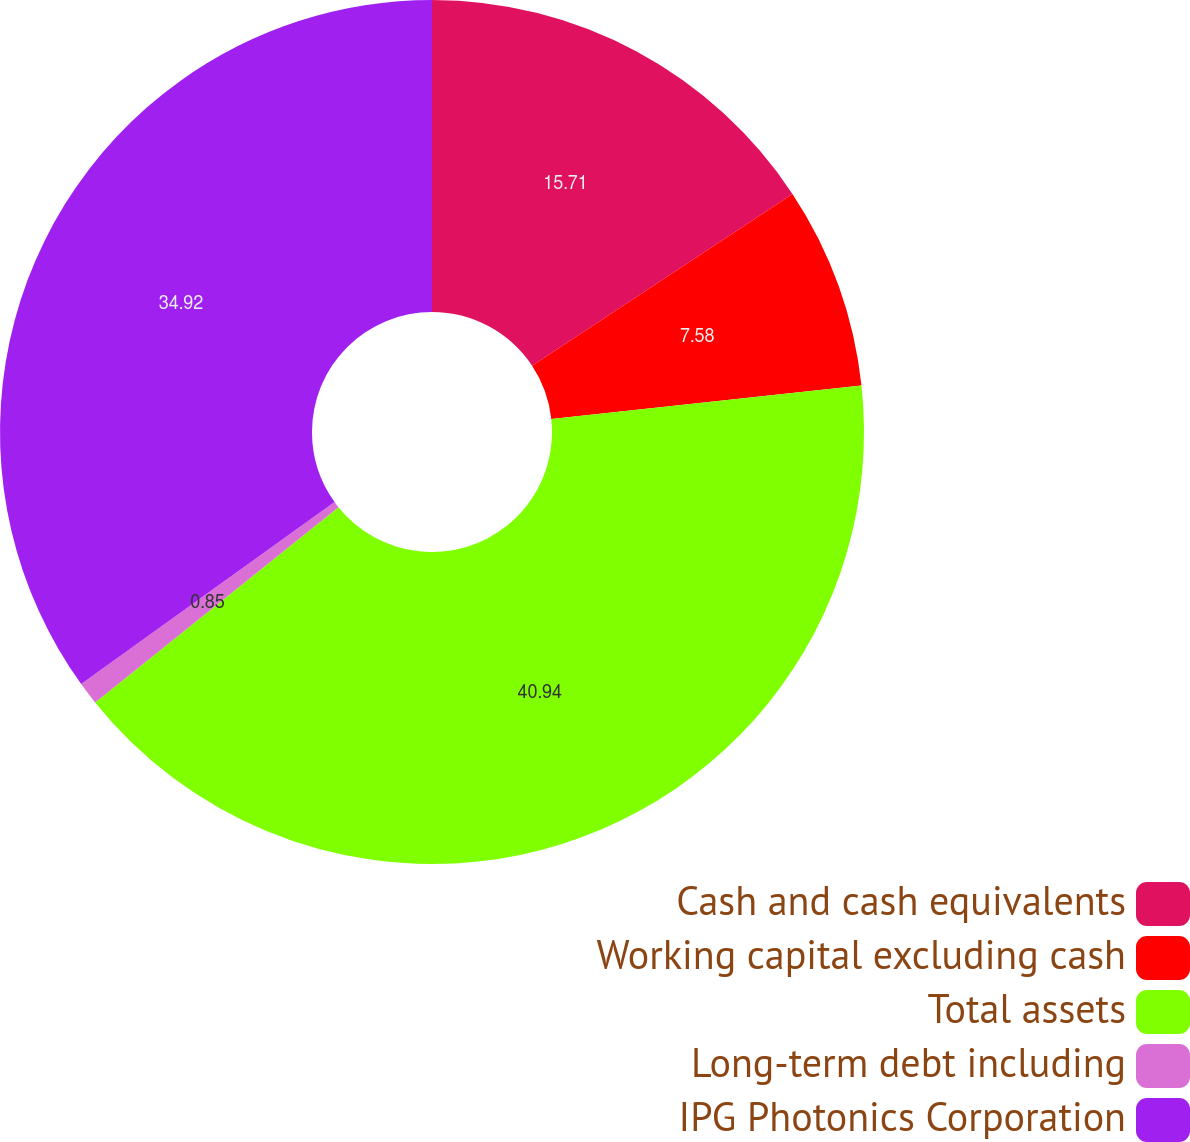<chart> <loc_0><loc_0><loc_500><loc_500><pie_chart><fcel>Cash and cash equivalents<fcel>Working capital excluding cash<fcel>Total assets<fcel>Long-term debt including<fcel>IPG Photonics Corporation<nl><fcel>15.71%<fcel>7.58%<fcel>40.95%<fcel>0.85%<fcel>34.92%<nl></chart> 